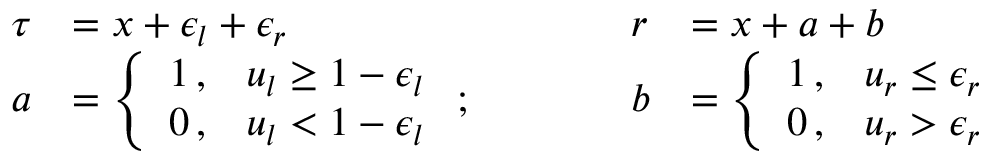Convert formula to latex. <formula><loc_0><loc_0><loc_500><loc_500>\begin{array} { l l l l } { \tau } & { = x + \epsilon _ { l } + \epsilon _ { r } } & { r } & { = x + a + b } \\ { a } & { = \left \{ \begin{array} { l l } { 1 \, , } & { u _ { l } \geq 1 - \epsilon _ { l } } \\ { 0 \, , } & { u _ { l } < 1 - \epsilon _ { l } } \end{array} ; \quad } & { b } & { = \left \{ \begin{array} { l l } { 1 \, , } & { u _ { r } \leq \epsilon _ { r } } \\ { 0 \, , } & { u _ { r } > \epsilon _ { r } } \end{array} } \end{array}</formula> 